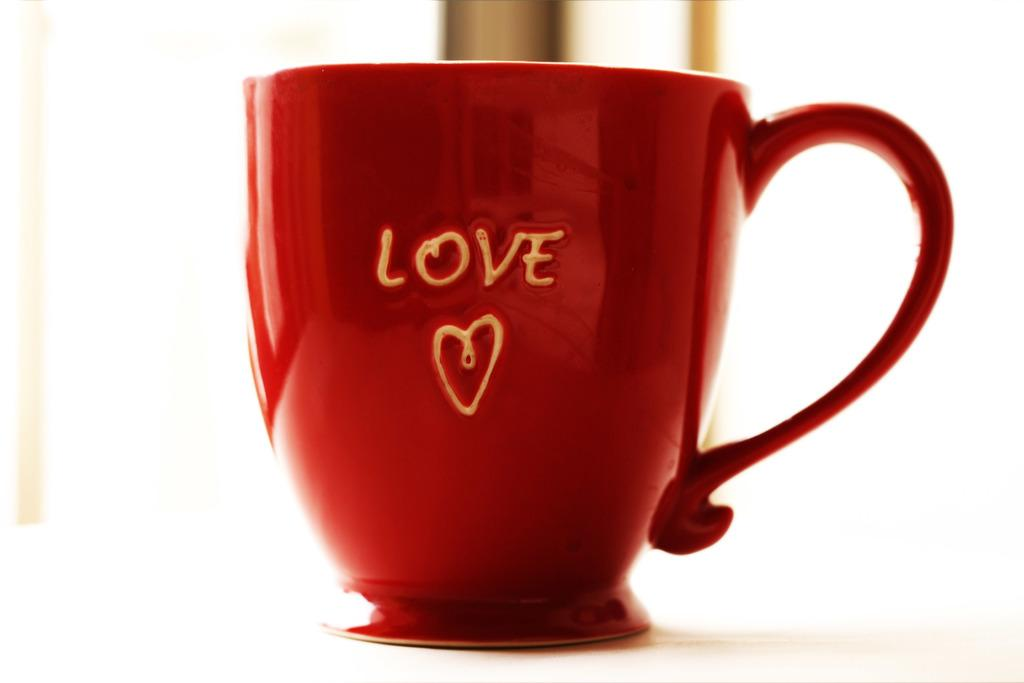What color is the cup that is visible in the image? There is a red cup in the image. What word is written on the cup? The word "LOVE" is written on the cup. Where is the nearest hospital to the location of the red cup in the image? The provided facts do not give any information about the location of the red cup or the nearest hospital, so it cannot be determined from the image. 